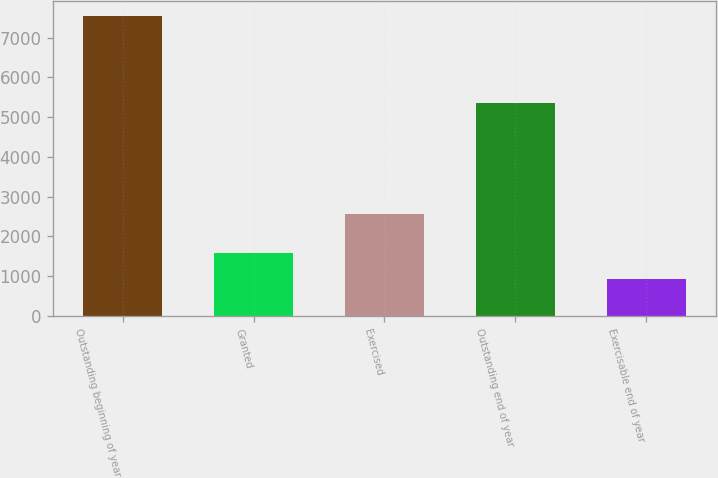Convert chart. <chart><loc_0><loc_0><loc_500><loc_500><bar_chart><fcel>Outstanding beginning of year<fcel>Granted<fcel>Exercised<fcel>Outstanding end of year<fcel>Exercisable end of year<nl><fcel>7538<fcel>1582.7<fcel>2576<fcel>5361<fcel>921<nl></chart> 